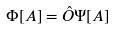<formula> <loc_0><loc_0><loc_500><loc_500>\Phi [ A ] = \hat { O } \Psi [ A ]</formula> 